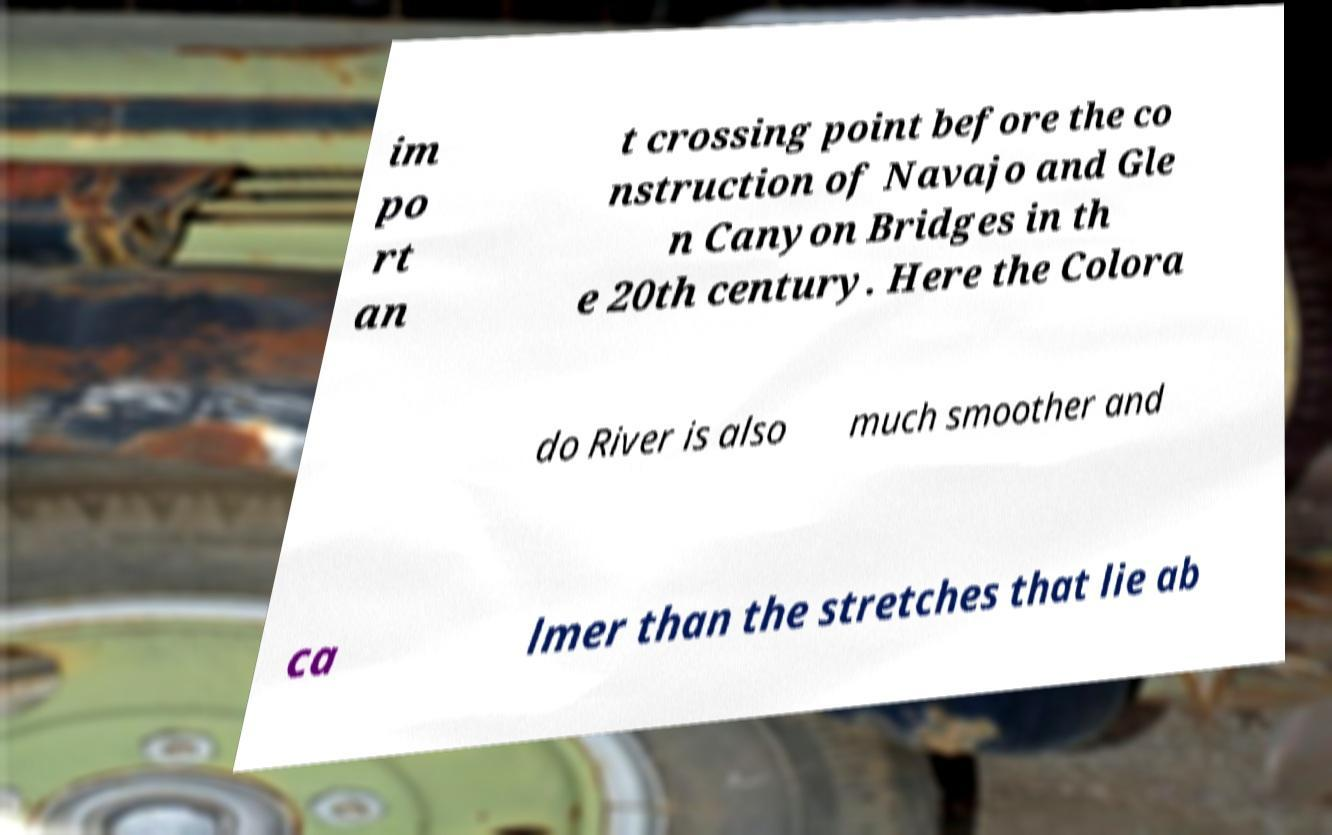Could you assist in decoding the text presented in this image and type it out clearly? im po rt an t crossing point before the co nstruction of Navajo and Gle n Canyon Bridges in th e 20th century. Here the Colora do River is also much smoother and ca lmer than the stretches that lie ab 